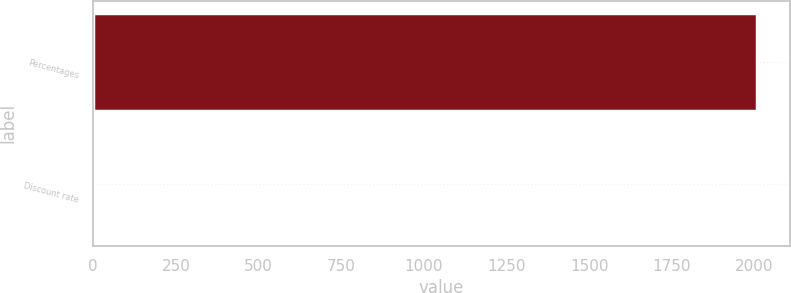Convert chart to OTSL. <chart><loc_0><loc_0><loc_500><loc_500><bar_chart><fcel>Percentages<fcel>Discount rate<nl><fcel>2007<fcel>6.5<nl></chart> 